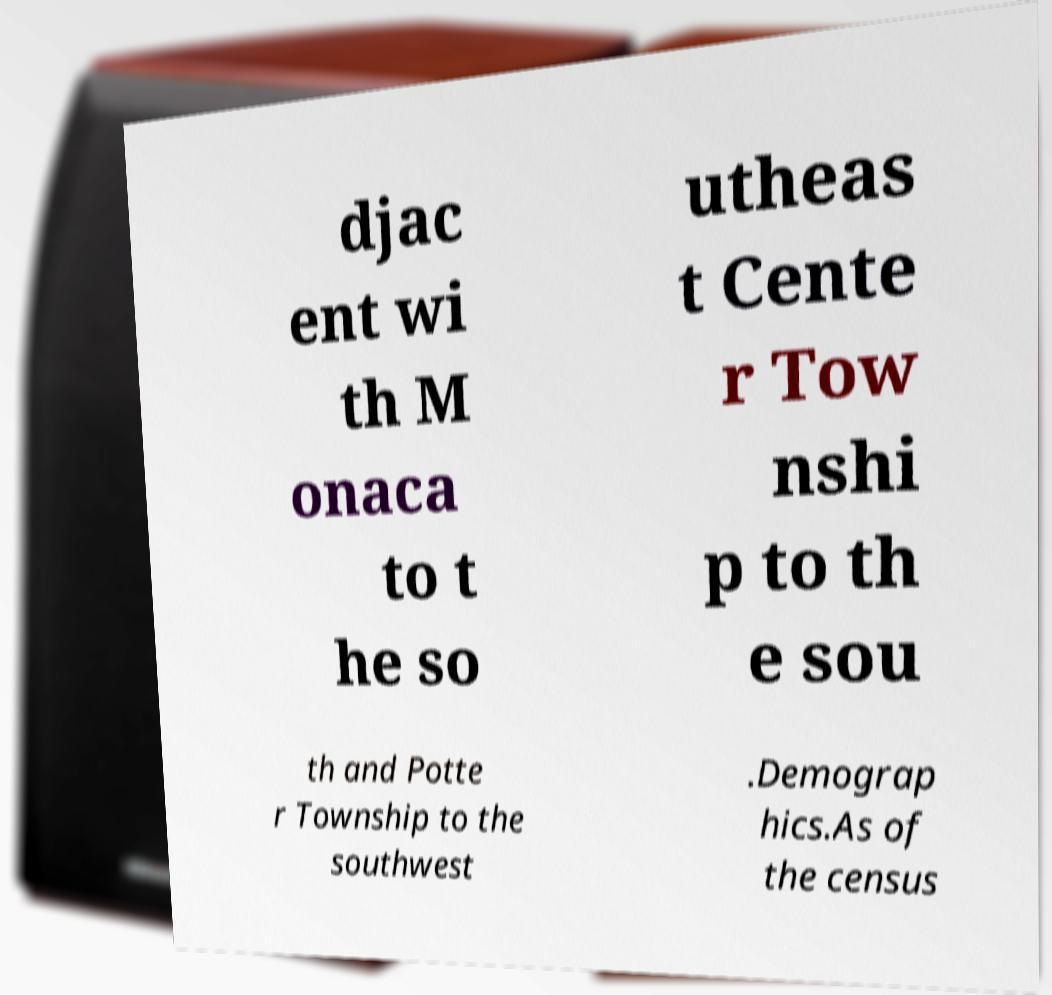Please identify and transcribe the text found in this image. djac ent wi th M onaca to t he so utheas t Cente r Tow nshi p to th e sou th and Potte r Township to the southwest .Demograp hics.As of the census 